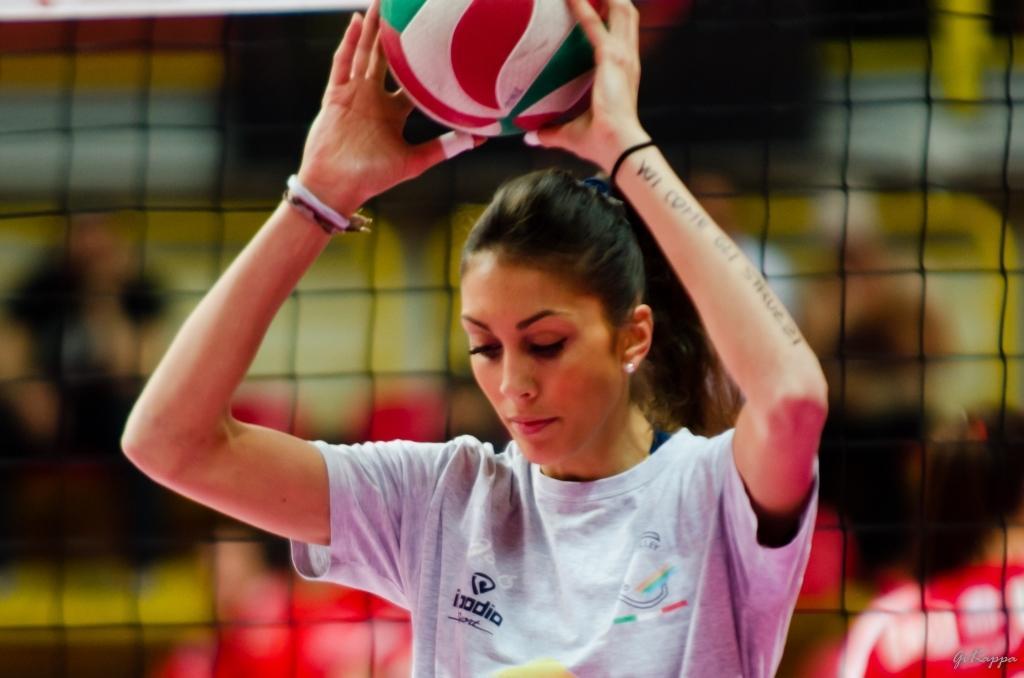Can you describe this image briefly? Here we can see a woman holding a ball with her hands and there is a mesh. There is a blur background. 